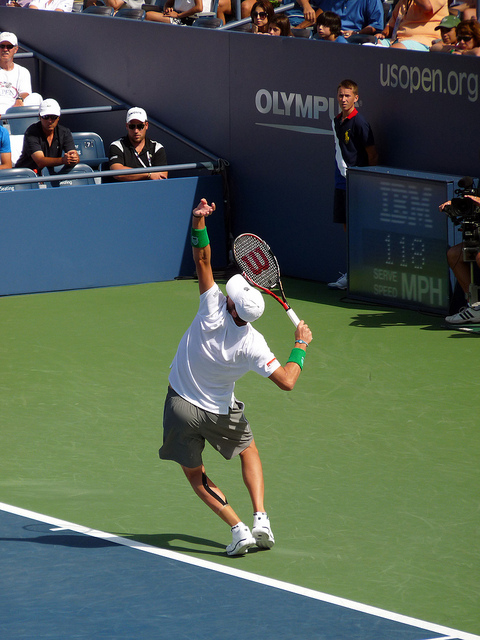Please transcribe the text information in this image. usopen.org IBM 118 MPH W OLYMPIC 